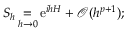<formula> <loc_0><loc_0><loc_500><loc_500>S _ { h } = _ { h \to 0 } { e } ^ { i h H } + \mathcal { O } ( h ^ { p + 1 } ) ;</formula> 